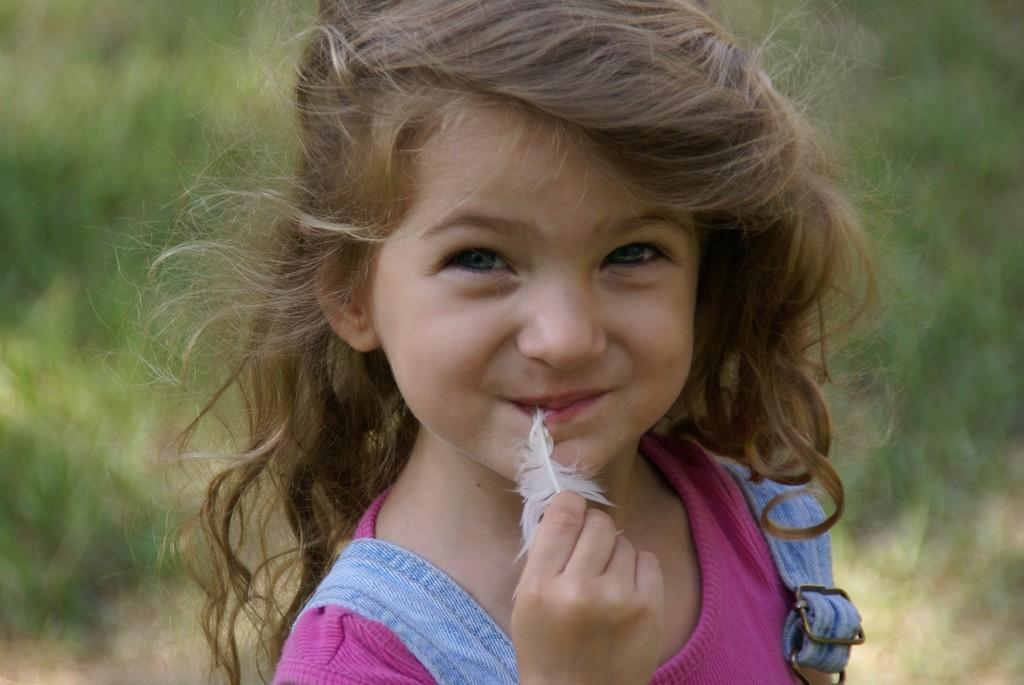Who is the main subject in the foreground of the image? There is a girl in the foreground of the image. What is the girl holding in her hand? A: The girl appears to be holding a feather in her hand. What is the girl's facial expression in the image? The girl is smiling. How is the background of the girl depicted in the image? The background of the girl is blurred. What type of circle can be seen in the image? There is no circle present in the image. Is there a group of people visible in the image? No, there is only one girl visible in the image. 